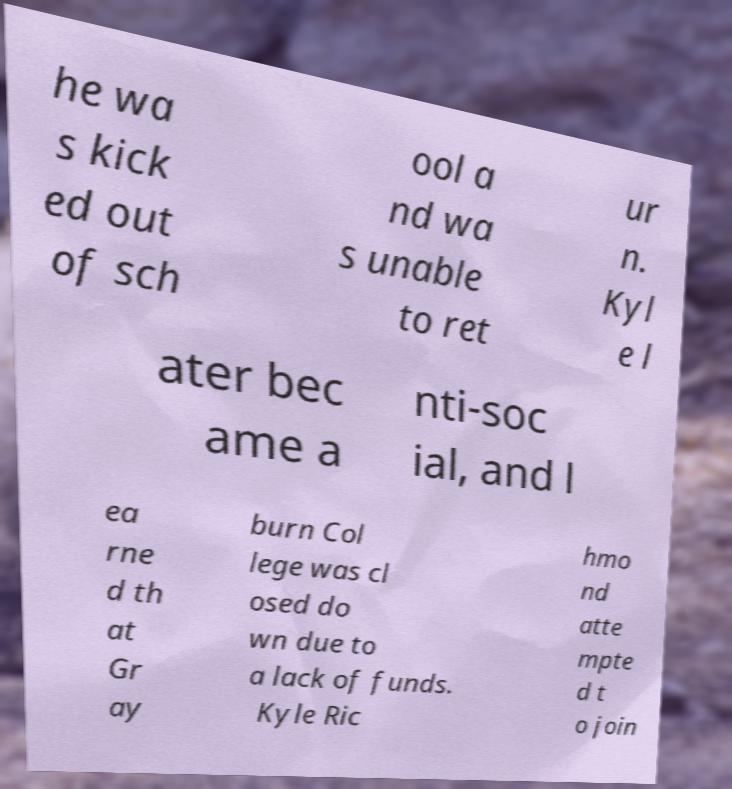Please read and relay the text visible in this image. What does it say? he wa s kick ed out of sch ool a nd wa s unable to ret ur n. Kyl e l ater bec ame a nti-soc ial, and l ea rne d th at Gr ay burn Col lege was cl osed do wn due to a lack of funds. Kyle Ric hmo nd atte mpte d t o join 